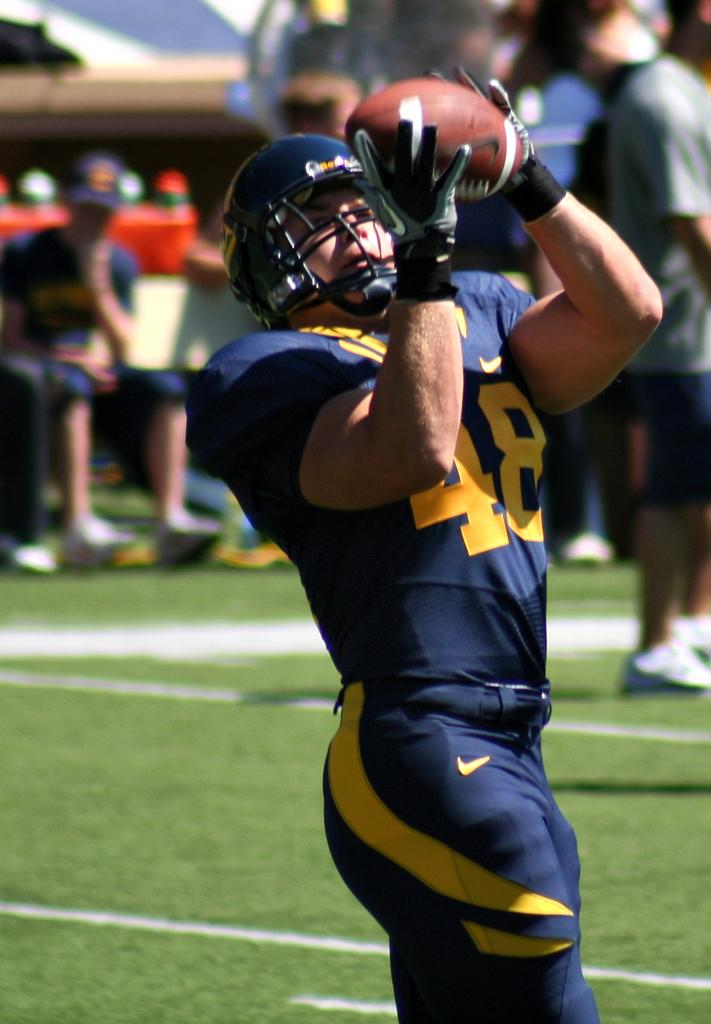Who is the main subject in the image? There is a man in the image. What is the man wearing on his head? The man is wearing a helmet. What is the man holding in his hand? The man is holding a ball. Where is the man standing in the image? The man is standing on a path. Can you describe the people behind the man? The people behind the man are blurred. What is the time displayed on the man's heart in the image? There is no time displayed on the man's heart in the image, as the man is wearing a helmet and not showing his heart. 